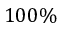Convert formula to latex. <formula><loc_0><loc_0><loc_500><loc_500>1 0 0 \%</formula> 